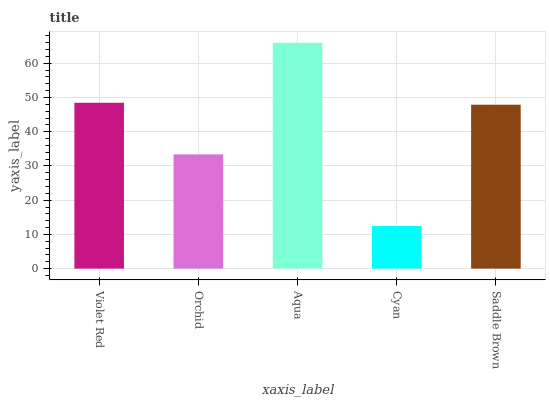Is Cyan the minimum?
Answer yes or no. Yes. Is Aqua the maximum?
Answer yes or no. Yes. Is Orchid the minimum?
Answer yes or no. No. Is Orchid the maximum?
Answer yes or no. No. Is Violet Red greater than Orchid?
Answer yes or no. Yes. Is Orchid less than Violet Red?
Answer yes or no. Yes. Is Orchid greater than Violet Red?
Answer yes or no. No. Is Violet Red less than Orchid?
Answer yes or no. No. Is Saddle Brown the high median?
Answer yes or no. Yes. Is Saddle Brown the low median?
Answer yes or no. Yes. Is Aqua the high median?
Answer yes or no. No. Is Violet Red the low median?
Answer yes or no. No. 